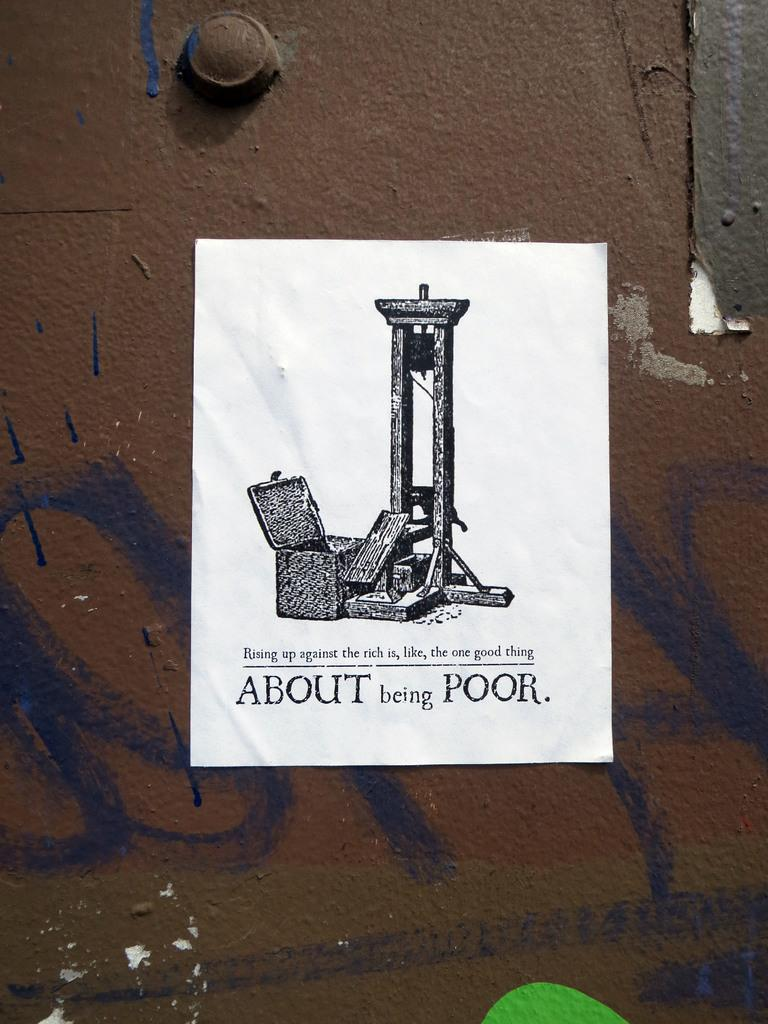<image>
Offer a succinct explanation of the picture presented. A picture of a guillotine and the tagline About Being Poor. 